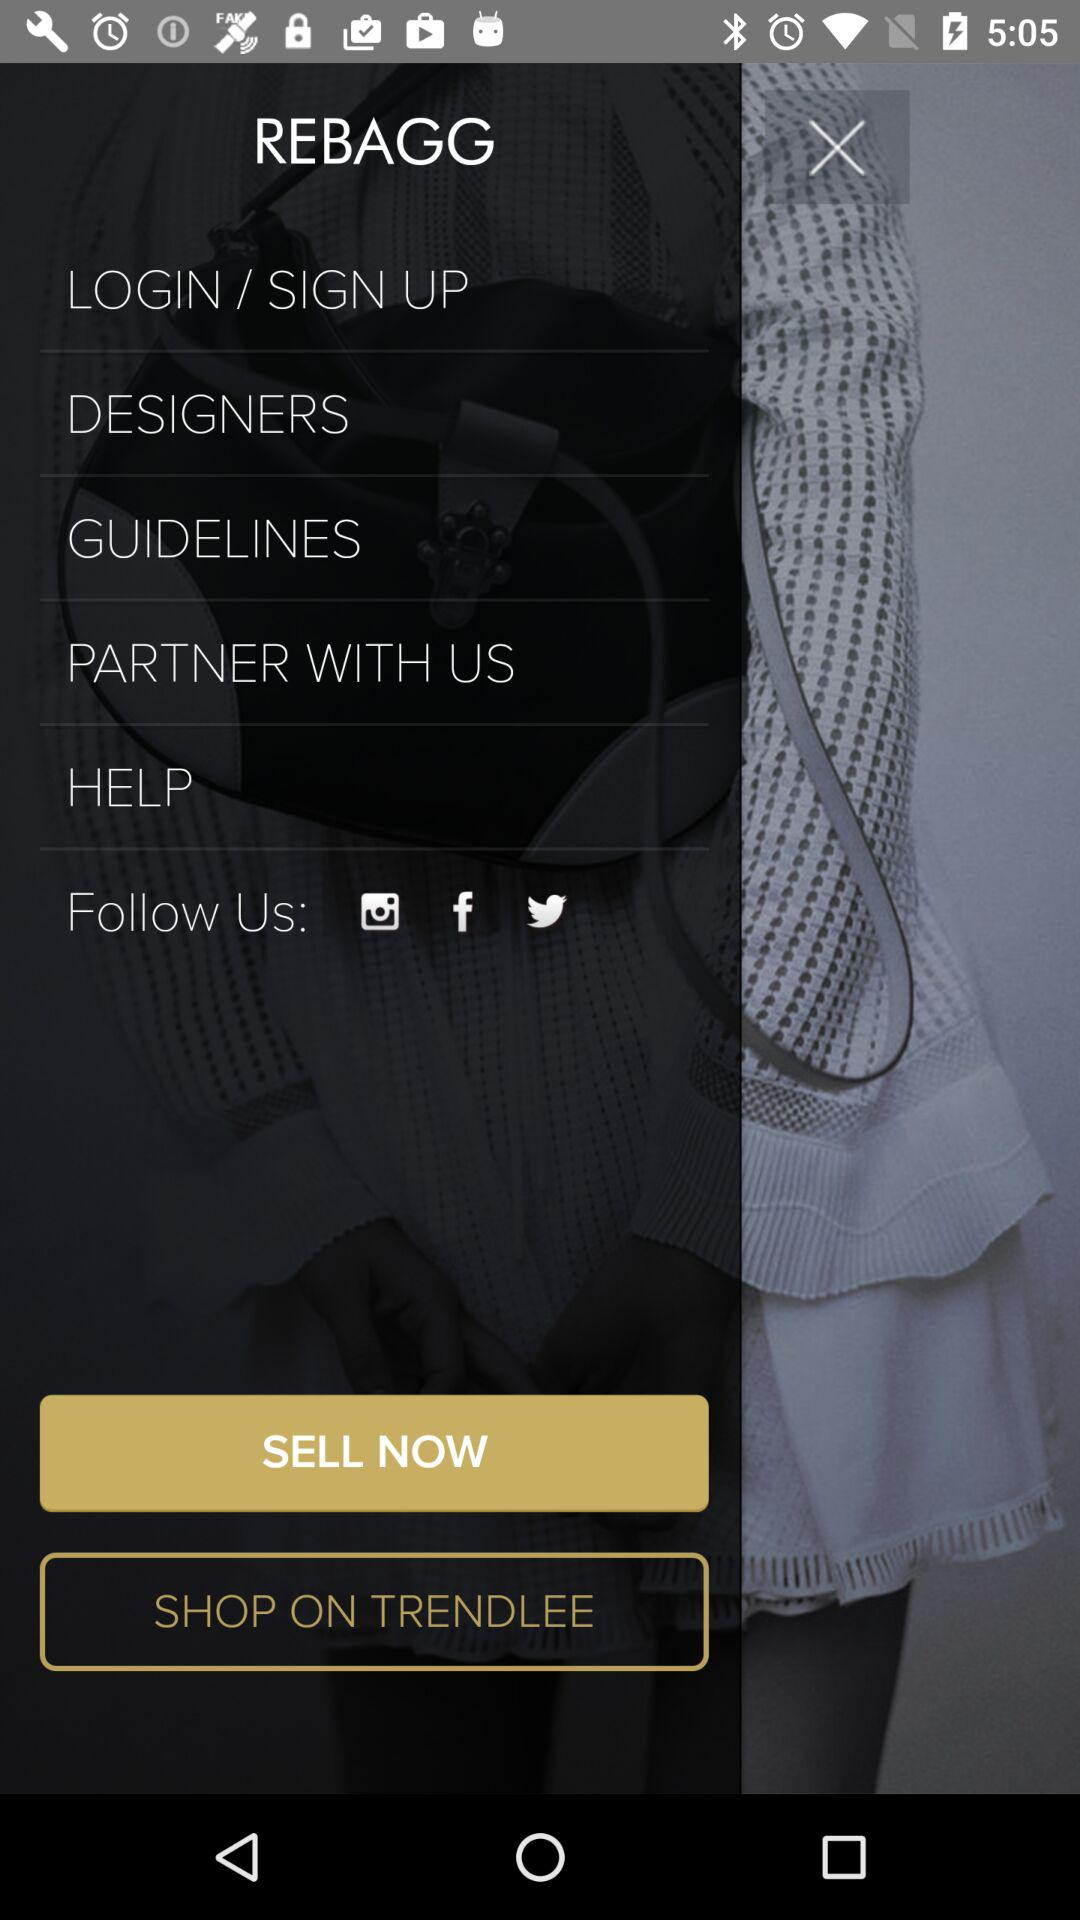On which online platforms can I follow "REBAGG"? You can follow "REBAGG" on "Instagram", "Facebook" and "Twitter". 